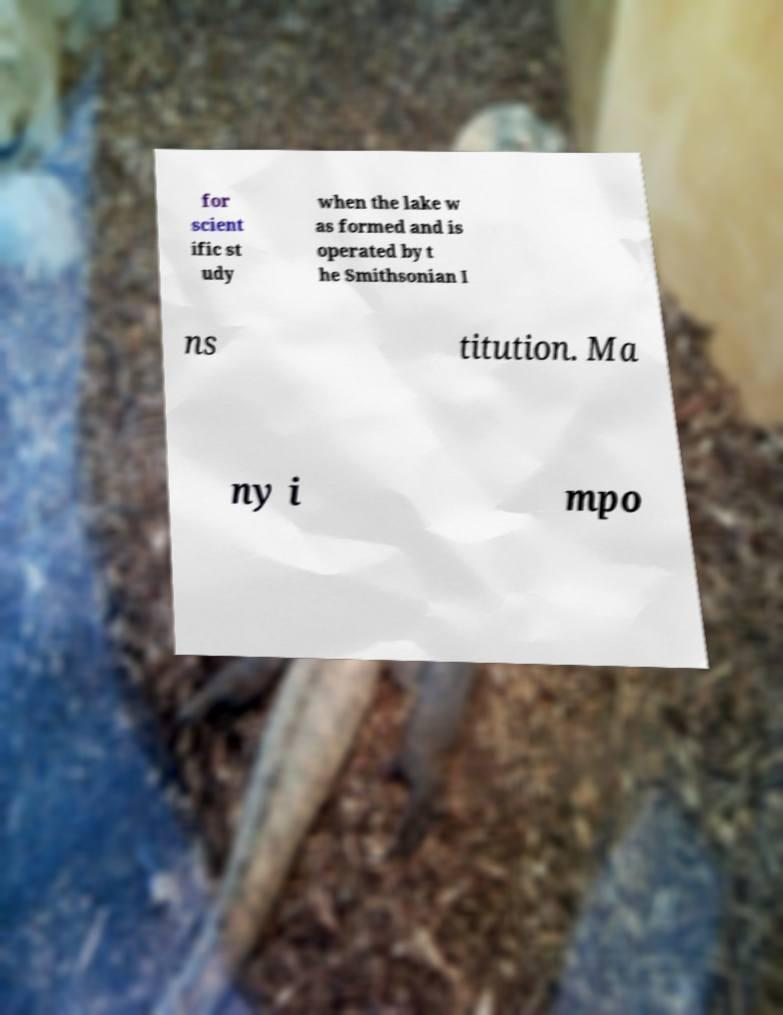What messages or text are displayed in this image? I need them in a readable, typed format. for scient ific st udy when the lake w as formed and is operated by t he Smithsonian I ns titution. Ma ny i mpo 